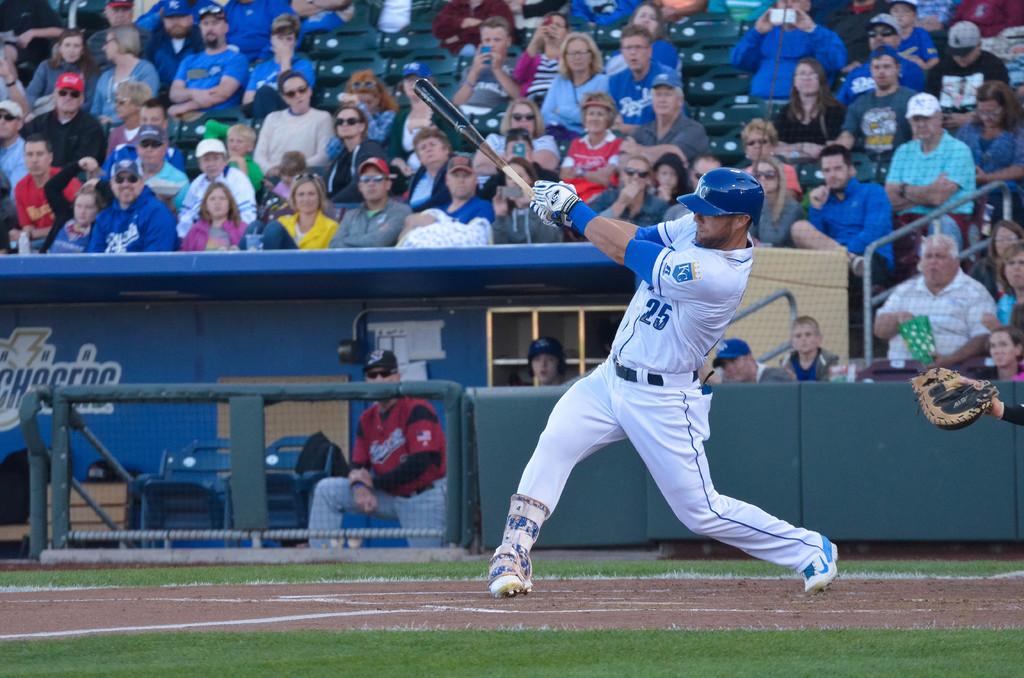What is the batter's number?
Your answer should be compact. 25. How many digits are in the player's number?
Offer a very short reply. 2. 